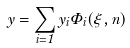Convert formula to latex. <formula><loc_0><loc_0><loc_500><loc_500>y = \sum _ { i = 1 } y _ { i } \Phi _ { i } ( \xi , n )</formula> 